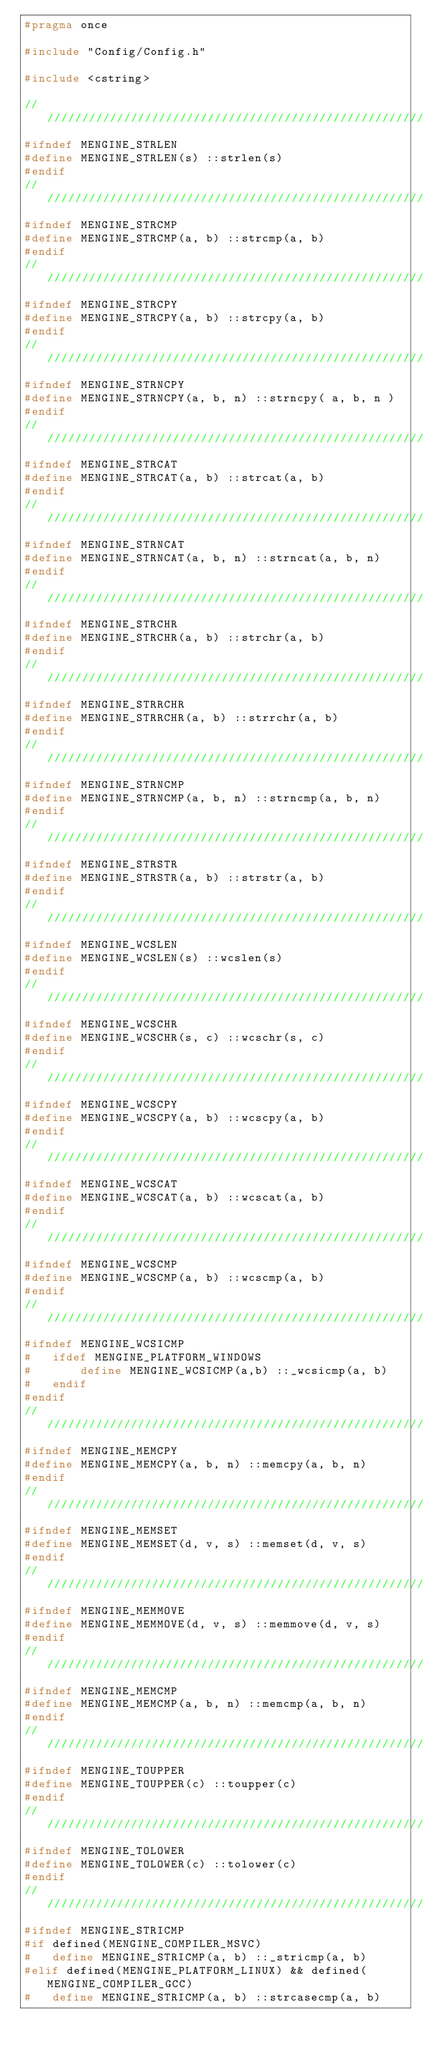Convert code to text. <code><loc_0><loc_0><loc_500><loc_500><_C_>#pragma once

#include "Config/Config.h"

#include <cstring>

//////////////////////////////////////////////////////////////////////////
#ifndef MENGINE_STRLEN
#define MENGINE_STRLEN(s) ::strlen(s)
#endif
//////////////////////////////////////////////////////////////////////////
#ifndef MENGINE_STRCMP
#define MENGINE_STRCMP(a, b) ::strcmp(a, b)
#endif
//////////////////////////////////////////////////////////////////////////
#ifndef MENGINE_STRCPY
#define MENGINE_STRCPY(a, b) ::strcpy(a, b)
#endif
//////////////////////////////////////////////////////////////////////////
#ifndef MENGINE_STRNCPY
#define MENGINE_STRNCPY(a, b, n) ::strncpy( a, b, n )
#endif
//////////////////////////////////////////////////////////////////////////
#ifndef MENGINE_STRCAT
#define MENGINE_STRCAT(a, b) ::strcat(a, b)
#endif
//////////////////////////////////////////////////////////////////////////
#ifndef MENGINE_STRNCAT
#define MENGINE_STRNCAT(a, b, n) ::strncat(a, b, n)
#endif
//////////////////////////////////////////////////////////////////////////
#ifndef MENGINE_STRCHR
#define MENGINE_STRCHR(a, b) ::strchr(a, b)
#endif
//////////////////////////////////////////////////////////////////////////
#ifndef MENGINE_STRRCHR
#define MENGINE_STRRCHR(a, b) ::strrchr(a, b)
#endif
//////////////////////////////////////////////////////////////////////////
#ifndef MENGINE_STRNCMP
#define MENGINE_STRNCMP(a, b, n) ::strncmp(a, b, n)
#endif
//////////////////////////////////////////////////////////////////////////
#ifndef MENGINE_STRSTR
#define MENGINE_STRSTR(a, b) ::strstr(a, b)
#endif
//////////////////////////////////////////////////////////////////////////
#ifndef MENGINE_WCSLEN
#define MENGINE_WCSLEN(s) ::wcslen(s)
#endif
//////////////////////////////////////////////////////////////////////////
#ifndef MENGINE_WCSCHR
#define MENGINE_WCSCHR(s, c) ::wcschr(s, c)
#endif
//////////////////////////////////////////////////////////////////////////
#ifndef MENGINE_WCSCPY
#define MENGINE_WCSCPY(a, b) ::wcscpy(a, b)
#endif
//////////////////////////////////////////////////////////////////////////
#ifndef MENGINE_WCSCAT
#define MENGINE_WCSCAT(a, b) ::wcscat(a, b)
#endif
//////////////////////////////////////////////////////////////////////////
#ifndef MENGINE_WCSCMP
#define MENGINE_WCSCMP(a, b) ::wcscmp(a, b)
#endif
//////////////////////////////////////////////////////////////////////////
#ifndef MENGINE_WCSICMP
#   ifdef MENGINE_PLATFORM_WINDOWS
#       define MENGINE_WCSICMP(a,b) ::_wcsicmp(a, b)
#   endif
#endif
//////////////////////////////////////////////////////////////////////////
#ifndef MENGINE_MEMCPY
#define MENGINE_MEMCPY(a, b, n) ::memcpy(a, b, n)
#endif
//////////////////////////////////////////////////////////////////////////
#ifndef MENGINE_MEMSET
#define MENGINE_MEMSET(d, v, s) ::memset(d, v, s)
#endif
//////////////////////////////////////////////////////////////////////////
#ifndef MENGINE_MEMMOVE
#define MENGINE_MEMMOVE(d, v, s) ::memmove(d, v, s)
#endif
//////////////////////////////////////////////////////////////////////////
#ifndef MENGINE_MEMCMP
#define MENGINE_MEMCMP(a, b, n) ::memcmp(a, b, n)
#endif
//////////////////////////////////////////////////////////////////////////
#ifndef MENGINE_TOUPPER
#define MENGINE_TOUPPER(c) ::toupper(c)
#endif
//////////////////////////////////////////////////////////////////////////
#ifndef MENGINE_TOLOWER
#define MENGINE_TOLOWER(c) ::tolower(c)
#endif
//////////////////////////////////////////////////////////////////////////
#ifndef MENGINE_STRICMP
#if defined(MENGINE_COMPILER_MSVC)
#   define MENGINE_STRICMP(a, b) ::_stricmp(a, b)
#elif defined(MENGINE_PLATFORM_LINUX) && defined(MENGINE_COMPILER_GCC)
#   define MENGINE_STRICMP(a, b) ::strcasecmp(a, b)</code> 